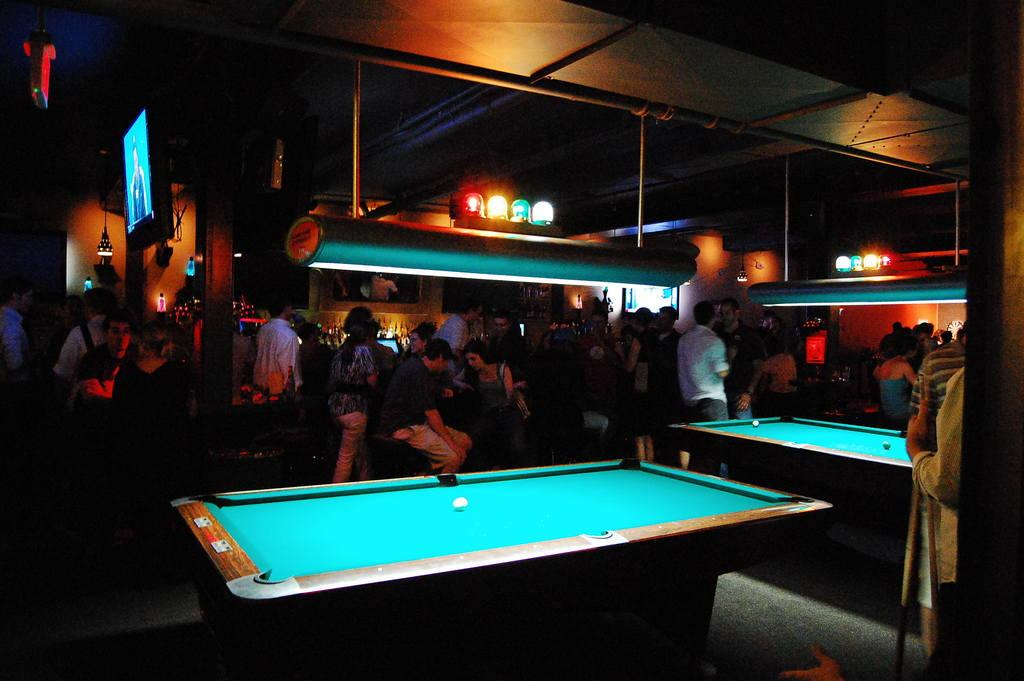What are the people in the image doing? There are persons standing and sitting in the image. What can be seen on the tables in the image? There are snooker tables with balls in the image. What type of lighting is present in the image? There are focusing lights in the image. What electronic device is visible in the image? There is a television in the image. What type of containers can be seen in the image? There are bottles visible in the image. What type of liquid can be seen coming out of the sky in the image? There is no liquid coming out of the sky in the image; the sky is not visible. How does the person in the image breathe while playing snooker? The person in the image is not shown breathing, and there is no information about their breathing in the image. 